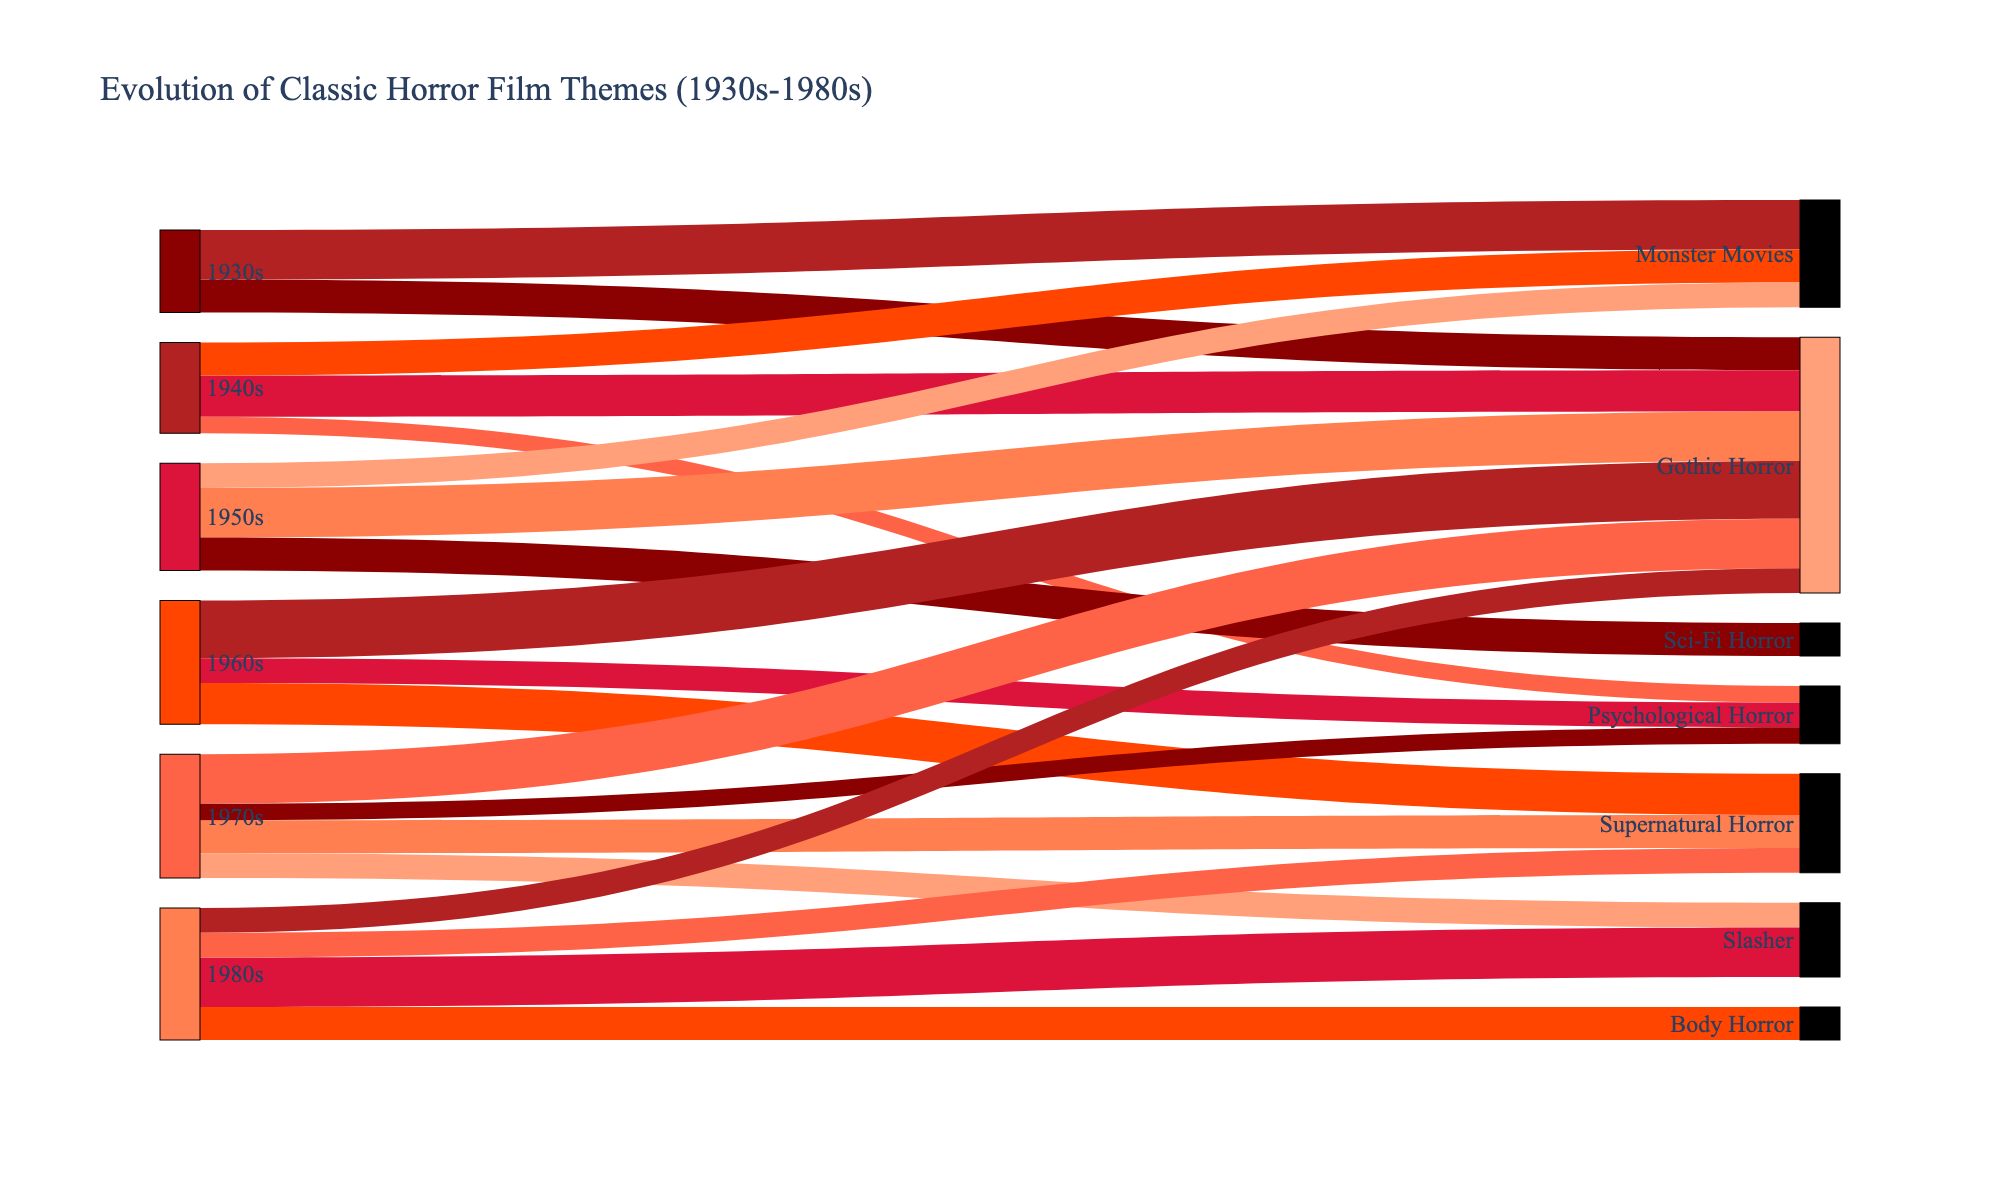Which decade had the highest number of Gothic Horror films? Look at the different colors corresponding to Gothic Horror across the decades and identify which decade has the largest value shown.
Answer: 1960s Which subgenre has the most significant presence in the 1980s? Check the links from the 1980s node and see which one carries the highest value.
Answer: Slasher How did the popularity of Monster Movies change from the 1930s to the 1950s? Compare the values of Monster Movies in the 1930s, 1940s, and 1950s to see the trend in values.
Answer: Decreased What common theme connects the 1940s and the 1970s, despite changes in other subgenres? Identify subgenres that have presence in both the 1940s and the 1970s by looking at the links from these decades.
Answer: Gothic Horror Which decade saw the introduction of Sci-Fi Horror? Observe the first decade that has a link corresponding to Sci-Fi Horror.
Answer: 1950s How does the value of Psychological Horror in the 1960s compare to that in the 1970s? Find the values associated with Psychological Horror in both the 1960s and 1970s and compare them.
Answer: Higher in the 1960s Out of all decades, which one showcased the most diversification of themes? Look at all the nodes for each decade and count the number of different outgoing links each one has.
Answer: 1970s Which subgenre experienced a decline from the 1940s to the 1980s? Analyze the link values for each subgenre over the decades and identify those that reduced in value from 1940s to the 1980s.
Answer: Gothic Horror How many subgenres are introduced in the 1960s that were not present in the 1950s? Compare the themes between the 1950s and 1960s and count the new subgenres appearing in the 1960s.
Answer: 1 (Supernatural Horror) Which decade has the lowest presence of Monster Movies? Find the decade with the smallest link value for Monster Movies.
Answer: 1950s 